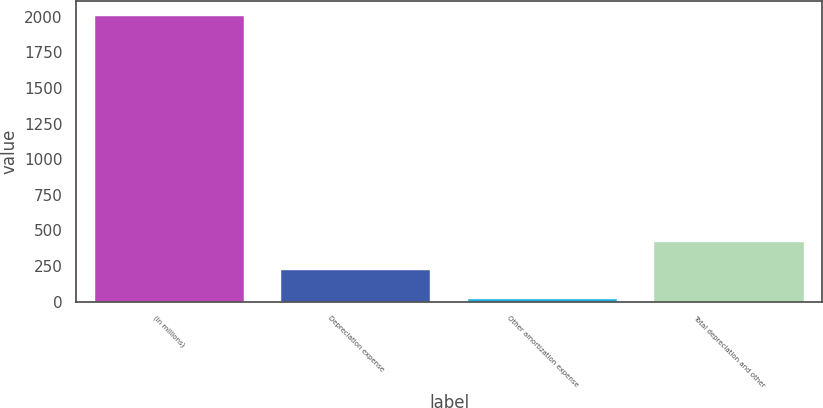Convert chart to OTSL. <chart><loc_0><loc_0><loc_500><loc_500><bar_chart><fcel>(In millions)<fcel>Depreciation expense<fcel>Other amortization expense<fcel>Total depreciation and other<nl><fcel>2009<fcel>219.8<fcel>21<fcel>418.6<nl></chart> 